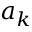<formula> <loc_0><loc_0><loc_500><loc_500>a _ { k }</formula> 